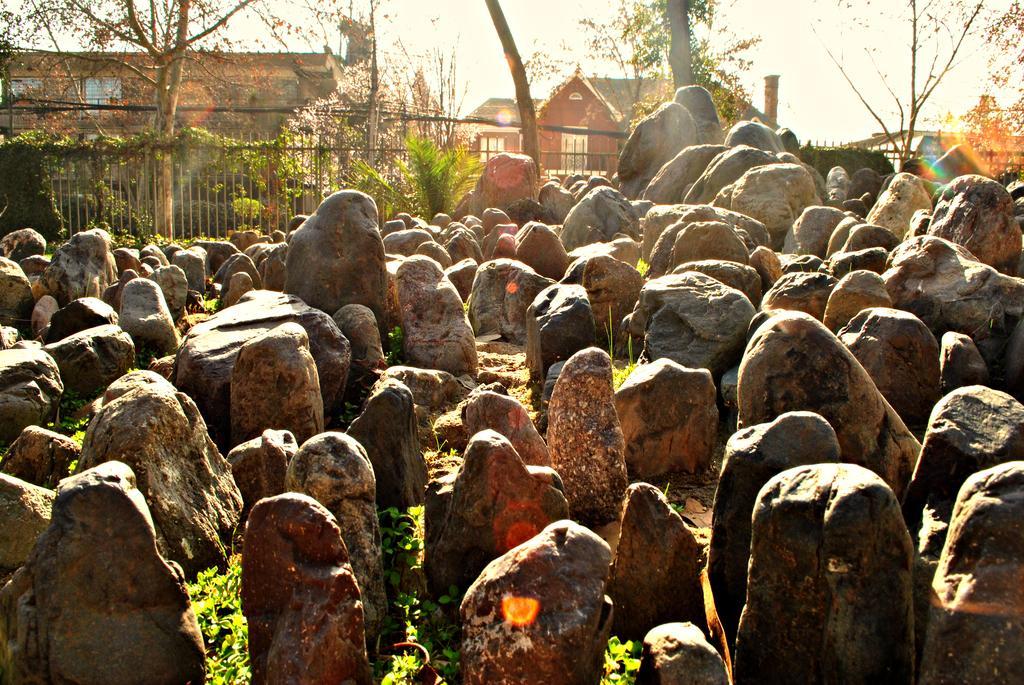Describe this image in one or two sentences. In this picture we can see few rocks, fence, trees and buildings. 